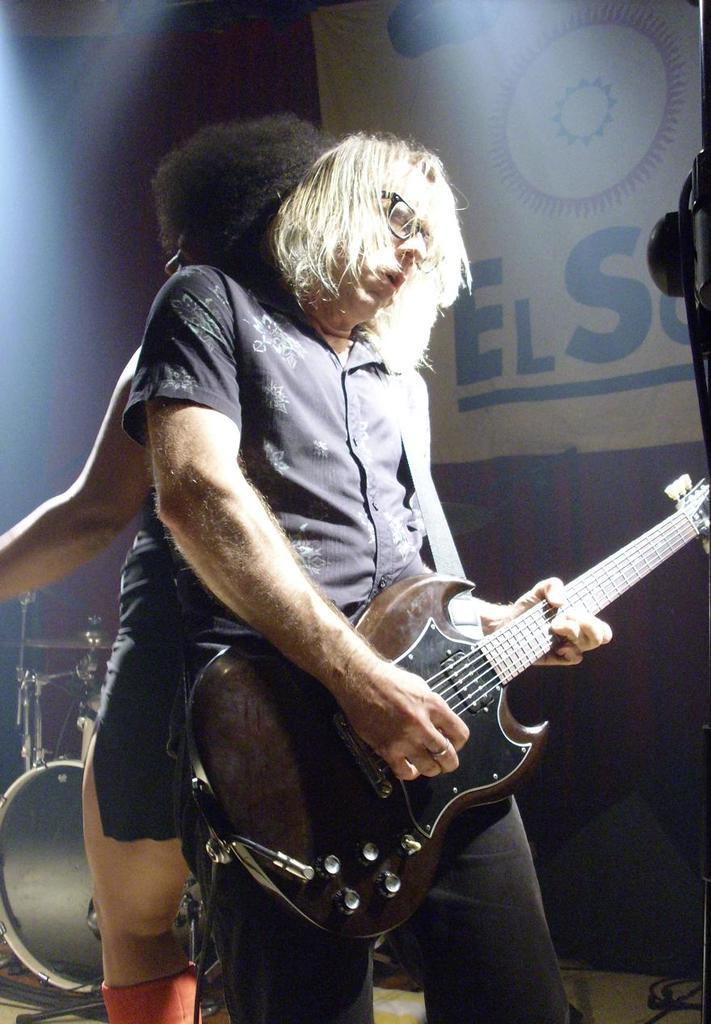In one or two sentences, can you explain what this image depicts? In this image we can see a person wearing blue color shirt, black color spectacles playing guitar and at the background of the image there is person who is beating drums and at the top of the image there is banner and some lights. 